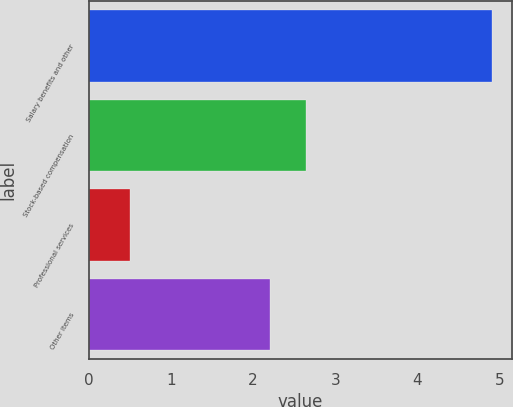<chart> <loc_0><loc_0><loc_500><loc_500><bar_chart><fcel>Salary benefits and other<fcel>Stock-based compensation<fcel>Professional services<fcel>Other items<nl><fcel>4.9<fcel>2.64<fcel>0.5<fcel>2.2<nl></chart> 